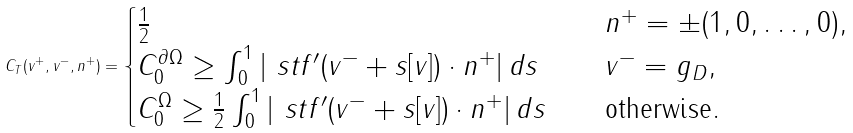Convert formula to latex. <formula><loc_0><loc_0><loc_500><loc_500>C _ { T } ( v ^ { + } , v ^ { - } , n ^ { + } ) = \begin{cases} \frac { 1 } { 2 } & \quad n ^ { + } = \pm ( 1 , 0 , \dots , 0 ) , \\ C _ { 0 } ^ { \partial \Omega } \geq \int _ { 0 } ^ { 1 } | \ s t f ^ { \prime } ( v ^ { - } + s [ v ] ) \cdot n ^ { + } | \, d s & \quad v ^ { - } = g _ { D } , \\ C _ { 0 } ^ { \Omega } \geq \frac { 1 } { 2 } \int _ { 0 } ^ { 1 } | \ s t f ^ { \prime } ( v ^ { - } + s [ v ] ) \cdot n ^ { + } | \, d s & \quad \text {otherwise} . \end{cases}</formula> 